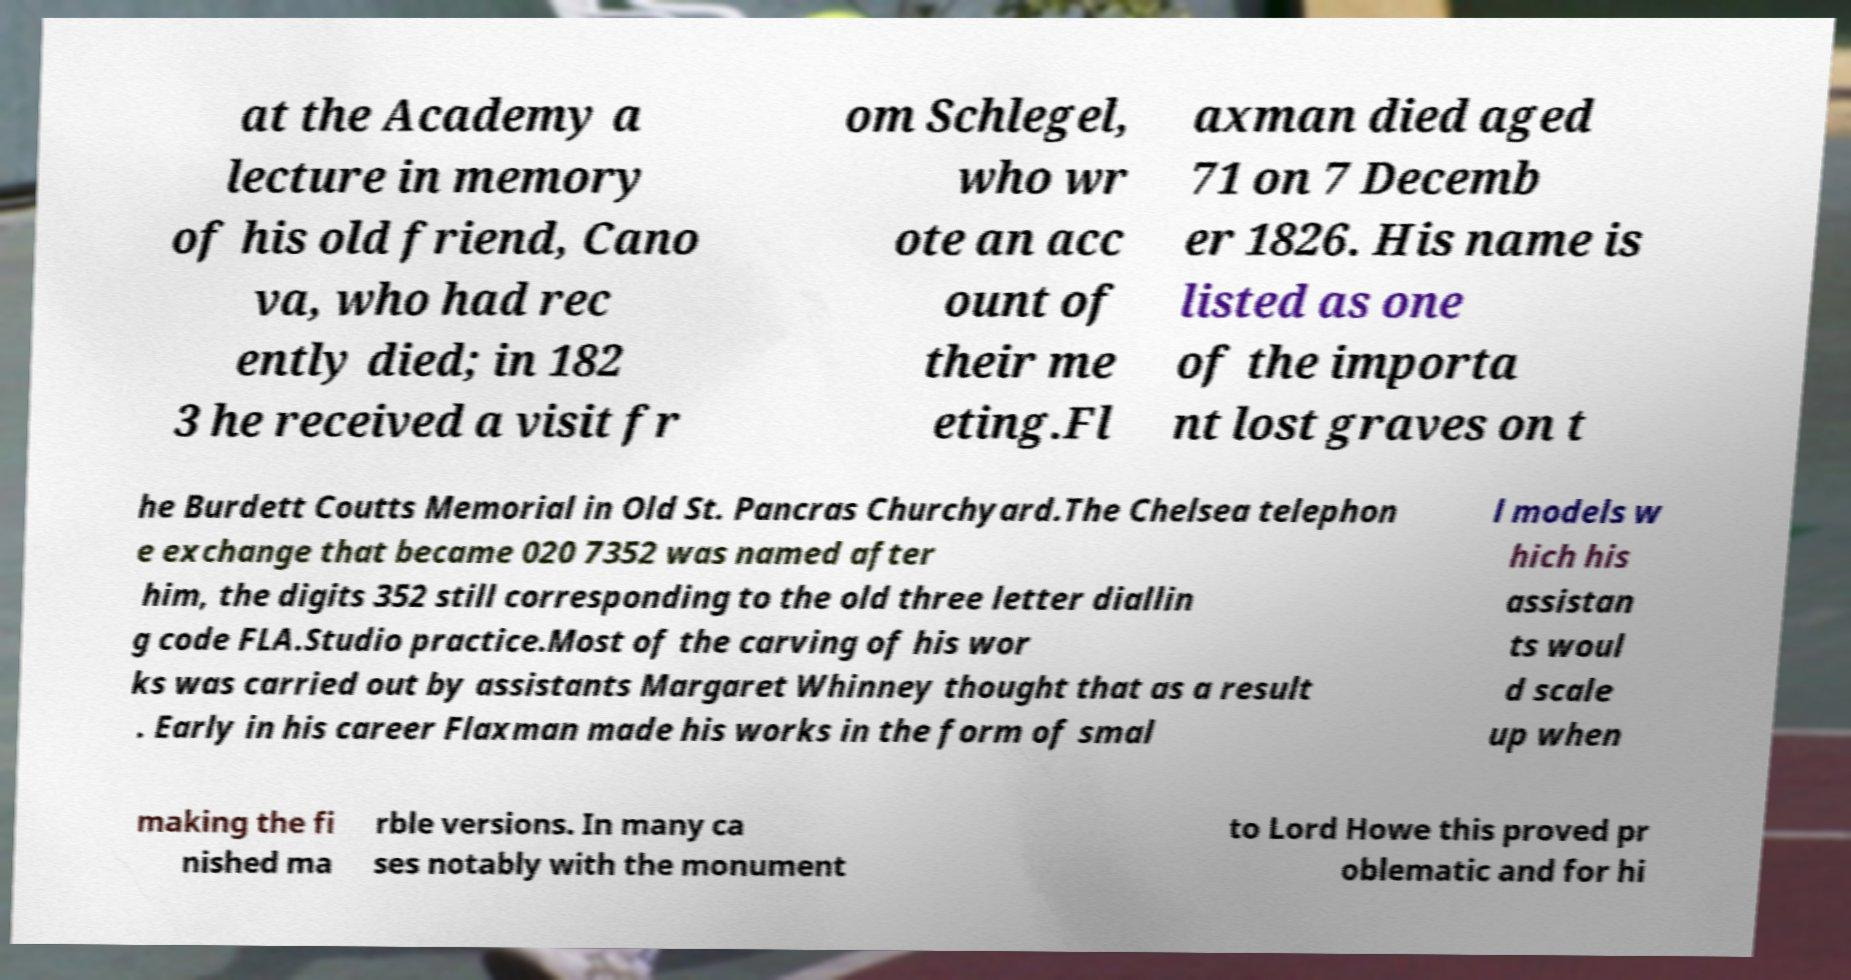Could you assist in decoding the text presented in this image and type it out clearly? at the Academy a lecture in memory of his old friend, Cano va, who had rec ently died; in 182 3 he received a visit fr om Schlegel, who wr ote an acc ount of their me eting.Fl axman died aged 71 on 7 Decemb er 1826. His name is listed as one of the importa nt lost graves on t he Burdett Coutts Memorial in Old St. Pancras Churchyard.The Chelsea telephon e exchange that became 020 7352 was named after him, the digits 352 still corresponding to the old three letter diallin g code FLA.Studio practice.Most of the carving of his wor ks was carried out by assistants Margaret Whinney thought that as a result . Early in his career Flaxman made his works in the form of smal l models w hich his assistan ts woul d scale up when making the fi nished ma rble versions. In many ca ses notably with the monument to Lord Howe this proved pr oblematic and for hi 